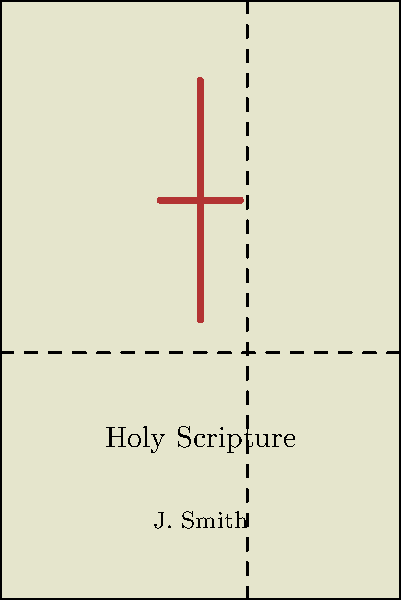In the layout design of this religious book cover, which principle of visual design is demonstrated by the dashed lines? To determine the principle of visual design demonstrated by the dashed lines, let's analyze the cover layout step-by-step:

1. The cover is divided by two dashed lines, one horizontal and one vertical.

2. These lines appear to divide the cover into sections that are not equal in size.

3. The ratio of these divisions is significant in design and art, known as the Golden Ratio.

4. The Golden Ratio, approximately 1:1.618, is often represented by the Greek letter φ (phi).

5. It can be calculated using the formula: $φ = \frac{1 + \sqrt{5}}{2} ≈ 1.618$

6. In the layout, the dashed lines are placed at approximately 61.8% of the width and height of the cover, which corresponds to the Golden Ratio.

7. The Golden Ratio is considered aesthetically pleasing and is often used in art, architecture, and design to create balanced and harmonious compositions.

8. By incorporating the Golden Ratio, the designer has utilized a principle of visual design that is particularly relevant to creating visually captivating designs for religious texts.

Therefore, the principle of visual design demonstrated by the dashed lines is the Golden Ratio, a key concept in creating balanced and aesthetically pleasing compositions.
Answer: Golden Ratio 